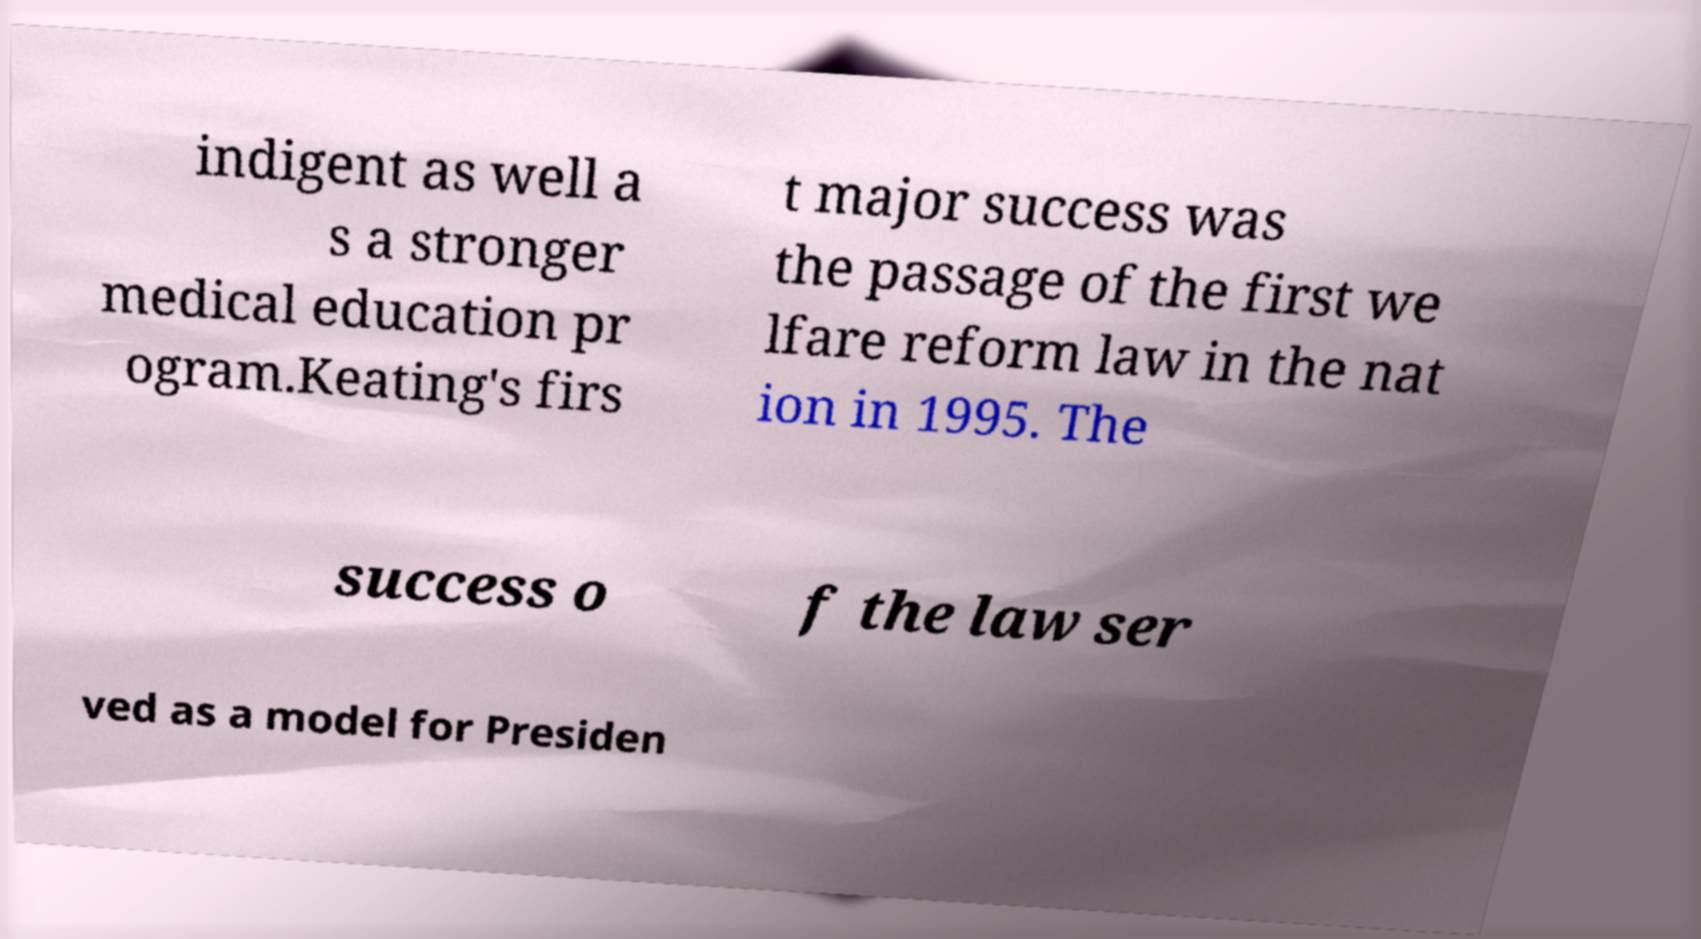Please read and relay the text visible in this image. What does it say? indigent as well a s a stronger medical education pr ogram.Keating's firs t major success was the passage of the first we lfare reform law in the nat ion in 1995. The success o f the law ser ved as a model for Presiden 